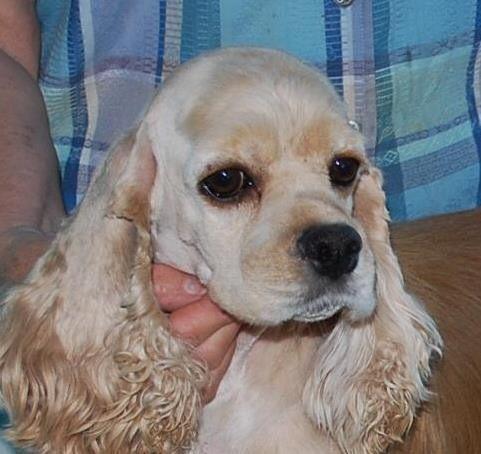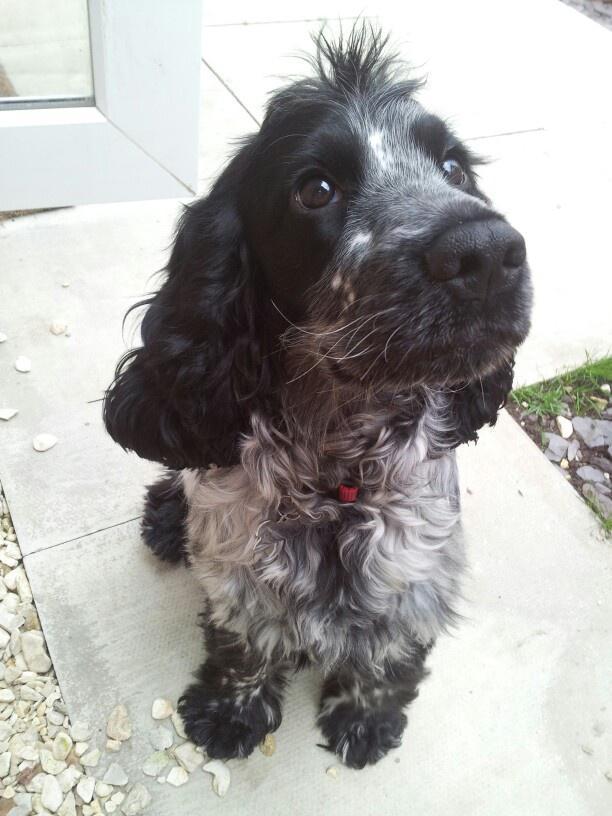The first image is the image on the left, the second image is the image on the right. For the images displayed, is the sentence "An image contains a human holding a dog." factually correct? Answer yes or no. Yes. The first image is the image on the left, the second image is the image on the right. Evaluate the accuracy of this statement regarding the images: "In one of the images, a human hand can be seen touching a single dog.". Is it true? Answer yes or no. Yes. 